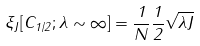<formula> <loc_0><loc_0><loc_500><loc_500>\xi _ { J } [ C _ { 1 / 2 } ; \lambda \sim \infty ] = \frac { 1 } { N } \frac { 1 } { 2 } \sqrt { \lambda J }</formula> 